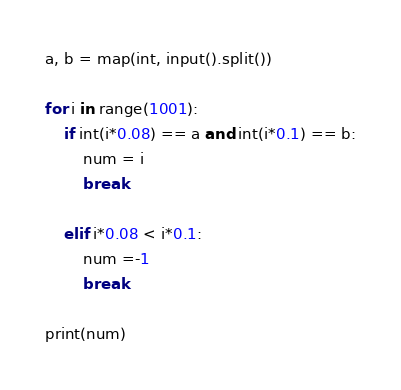<code> <loc_0><loc_0><loc_500><loc_500><_Python_>a, b = map(int, input().split())

for i in range(1001):
    if int(i*0.08) == a and int(i*0.1) == b:
        num = i
        break

    elif i*0.08 < i*0.1:
        num =-1
        break

print(num)
</code> 